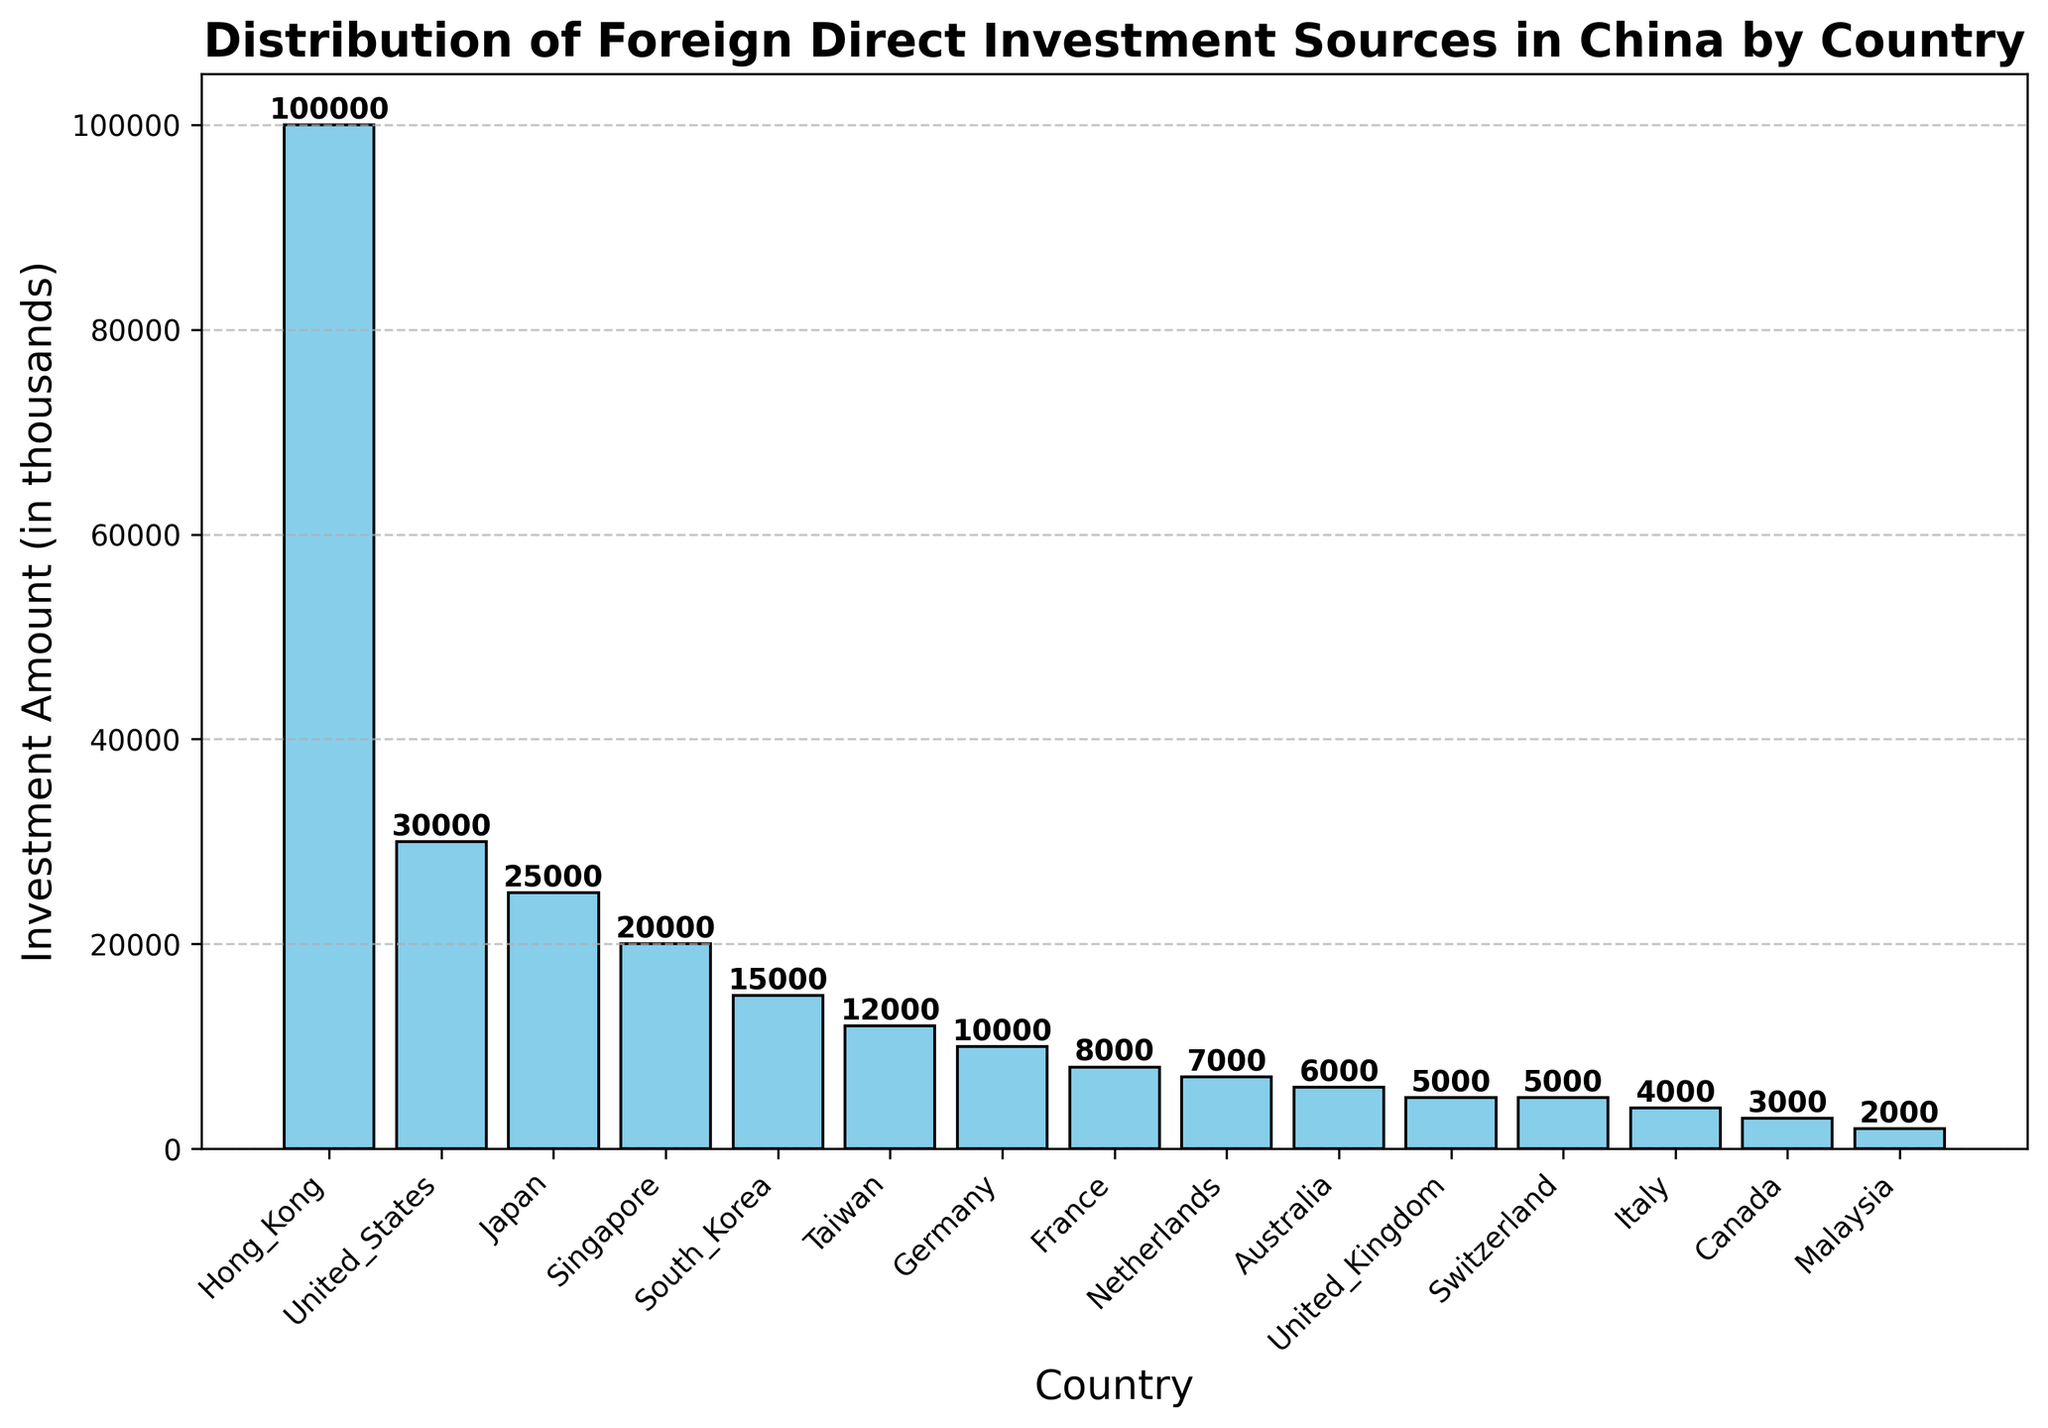Which country has the highest foreign direct investment in China? To find the country with the highest investment, look for the tallest bar in the histogram. The tallest bar corresponds to Hong Kong.
Answer: Hong Kong Which country has a lower investment amount: France or Germany? Compare the heights of the bars for France and Germany. The bar for Germany is taller than the one for France, indicating higher investment.
Answer: France What is the total foreign direct investment from the United States and Japan? Locate the bars for the United States and Japan and add their heights (investment amounts). The United States has 30,000 and Japan has 25,000. Adding them gives 30,000 + 25,000.
Answer: 55,000 Are there more countries with an investment amount greater than 8,000 or less than 8,000? Count the bars taller than 8,000 and compare with the count of bars shorter than 8,000. There are more countries with an investment amount less than 8,000.
Answer: Less than 8,000 What is the difference in investment amounts between South Korea and Taiwan? Find the bars representing South Korea and Taiwan and subtract the shorter bar (Taiwan - 12,000) from the taller bar (South Korea - 15,000). The difference is 15,000 - 12,000.
Answer: 3,000 Which countries have an equal amount of investment in China? Look for bars of equal heights. The bars for United Kingdom and Switzerland are of equal height at 5,000.
Answer: United Kingdom, Switzerland What is the average investment amount of the top 3 countries? Find the bars representing the top 3 countries (Hong Kong - 100,000, United States - 30,000, and Japan - 25,000). Sum these amounts and divide by 3: (100,000 + 30,000 + 25,000) / 3.
Answer: 51,667 Which country’s investment amount is closest to the median value of all investments listed? Calculate the median of the sorted investment amounts and find the country whose bar height is closest to this value. The median value in a sorted list of 15 entries is the 8th value, which is South Korea at 15,000.
Answer: South Korea Is the investment amount from Australia greater than the combined investment from Malaysia and Italy? Locate the bars for Australia, Malaysia, and Italy. Add the heights of Malaysia (2,000) and Italy (4,000) to compare with Australia (6,000). The combined investment from Malaysia and Italy is 2,000 + 4,000 = 6,000, which is equal to Australia.
Answer: No Which three countries have investment amounts less than 6,000? Identify the bars shorter than 6,000 and list the countries. Malaysia (2,000), Canada (3,000), and Italy (4,000).
Answer: Malaysia, Canada, Italy 